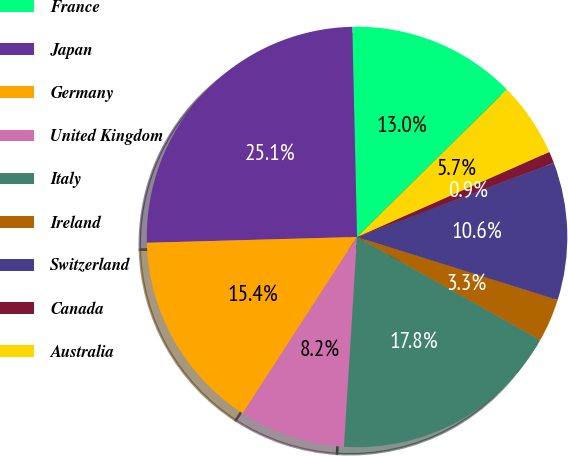Convert chart. <chart><loc_0><loc_0><loc_500><loc_500><pie_chart><fcel>France<fcel>Japan<fcel>Germany<fcel>United Kingdom<fcel>Italy<fcel>Ireland<fcel>Switzerland<fcel>Canada<fcel>Australia<nl><fcel>12.99%<fcel>25.08%<fcel>15.41%<fcel>8.16%<fcel>17.83%<fcel>3.32%<fcel>10.57%<fcel>0.9%<fcel>5.74%<nl></chart> 